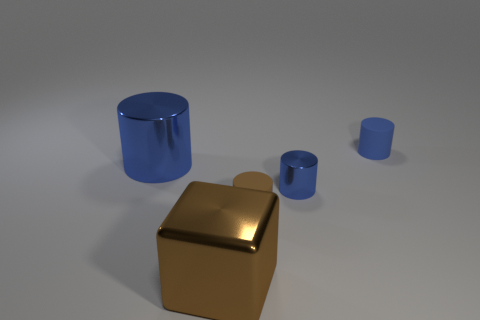Are there more big metallic blocks than tiny green blocks?
Offer a terse response. Yes. There is a small cylinder that is behind the large blue cylinder; what is its color?
Your answer should be compact. Blue. Is the number of tiny rubber objects right of the brown shiny object greater than the number of big yellow rubber cylinders?
Ensure brevity in your answer.  Yes. Are the large blue thing and the tiny brown cylinder made of the same material?
Make the answer very short. No. What number of other objects are there of the same shape as the brown metal object?
Offer a terse response. 0. What color is the metallic cylinder that is to the right of the blue metallic object that is on the left side of the small blue object in front of the blue matte cylinder?
Offer a very short reply. Blue. Is the shape of the big metallic thing in front of the large blue shiny thing the same as  the tiny metallic thing?
Your answer should be very brief. No. What number of red cylinders are there?
Give a very brief answer. 0. What number of blue cylinders have the same size as the blue rubber object?
Offer a terse response. 1. What is the material of the large brown thing?
Your response must be concise. Metal. 